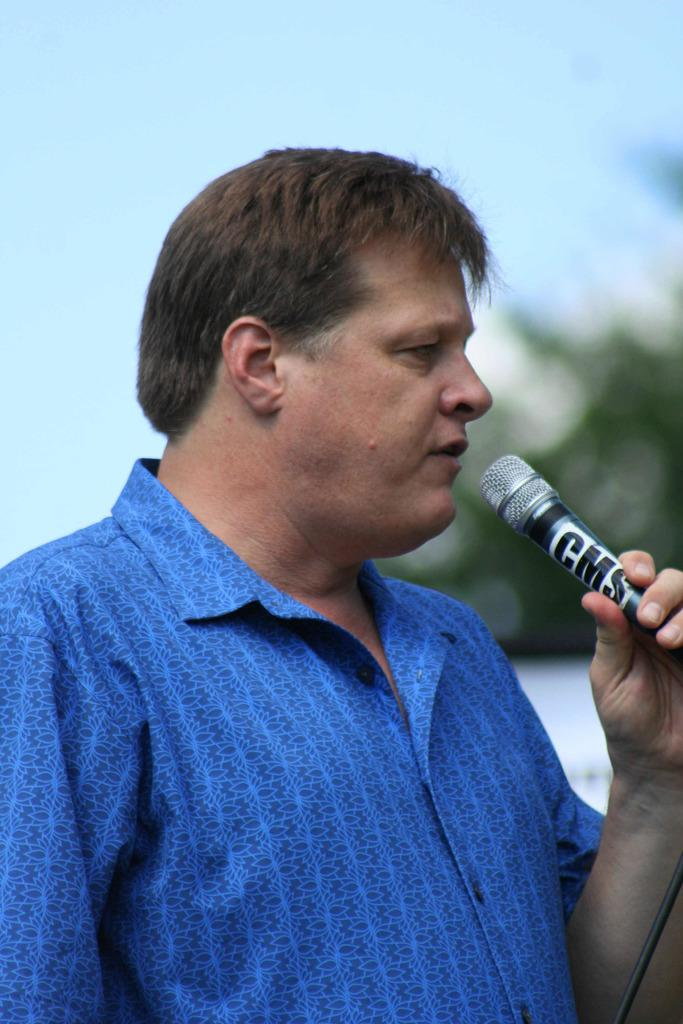Who is the main subject in the image? There is a man in the image. What is the man holding in his hand? The man is holding a microphone in his hand. What can be seen on the microphone? There is text on the microphone. What is visible at the top of the image? The sky is visible at the top of the image. How would you describe the background of the image? The background of the image is blurry. How many rabbits are sitting on the chair in the image? There are no rabbits or chairs present in the image. 